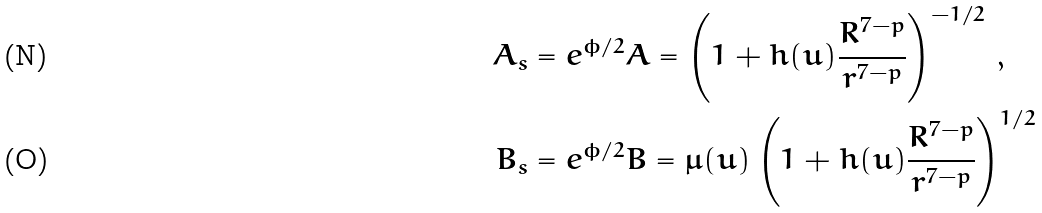Convert formula to latex. <formula><loc_0><loc_0><loc_500><loc_500>A _ { s } & = e ^ { \phi / 2 } A = \left ( 1 + h ( u ) \frac { R ^ { 7 - p } } { r ^ { 7 - p } } \right ) ^ { - 1 / 2 } \, , \\ B _ { s } & = e ^ { \phi / 2 } B = \mu ( u ) \left ( 1 + h ( u ) \frac { R ^ { 7 - p } } { r ^ { 7 - p } } \right ) ^ { 1 / 2 } \,</formula> 